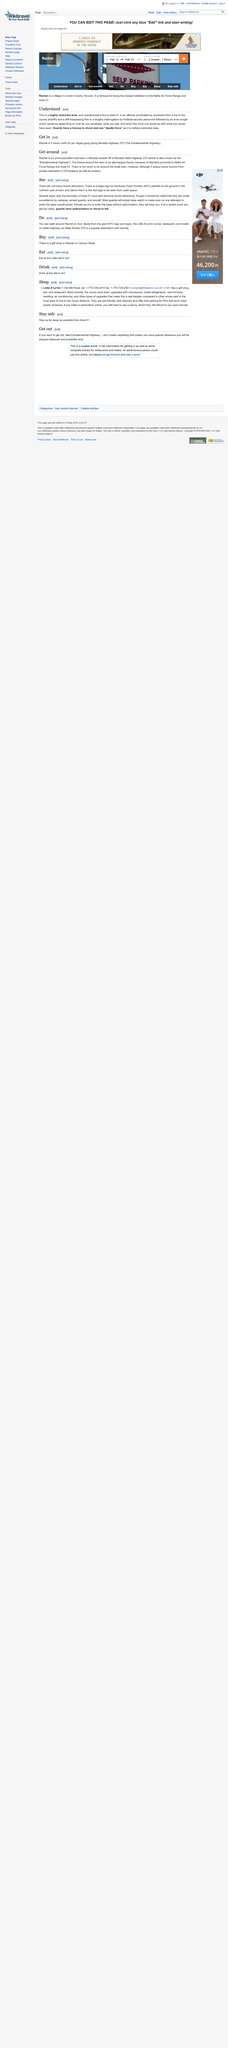Outline some significant characteristics in this image. If you approach Area 51 beyond a certain point, guards are authorized to use lethal force to prevent entry. There is a large logo for Kentucky Fried Chicken (KFC) painted on the ground in the northern part of the town near Area 51, which is the company's logo. Area 51 is a tourist attraction, with several signs near its boundary becoming popular among visitors. However, it is important to note that these signs are under surveillance by cameras, armed guards, and aircraft, and should not be used as a means of attempting to enter the facility. 